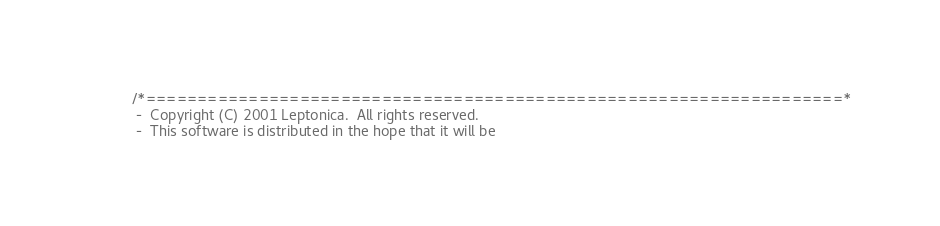<code> <loc_0><loc_0><loc_500><loc_500><_C_>/*====================================================================*
 -  Copyright (C) 2001 Leptonica.  All rights reserved.
 -  This software is distributed in the hope that it will be</code> 